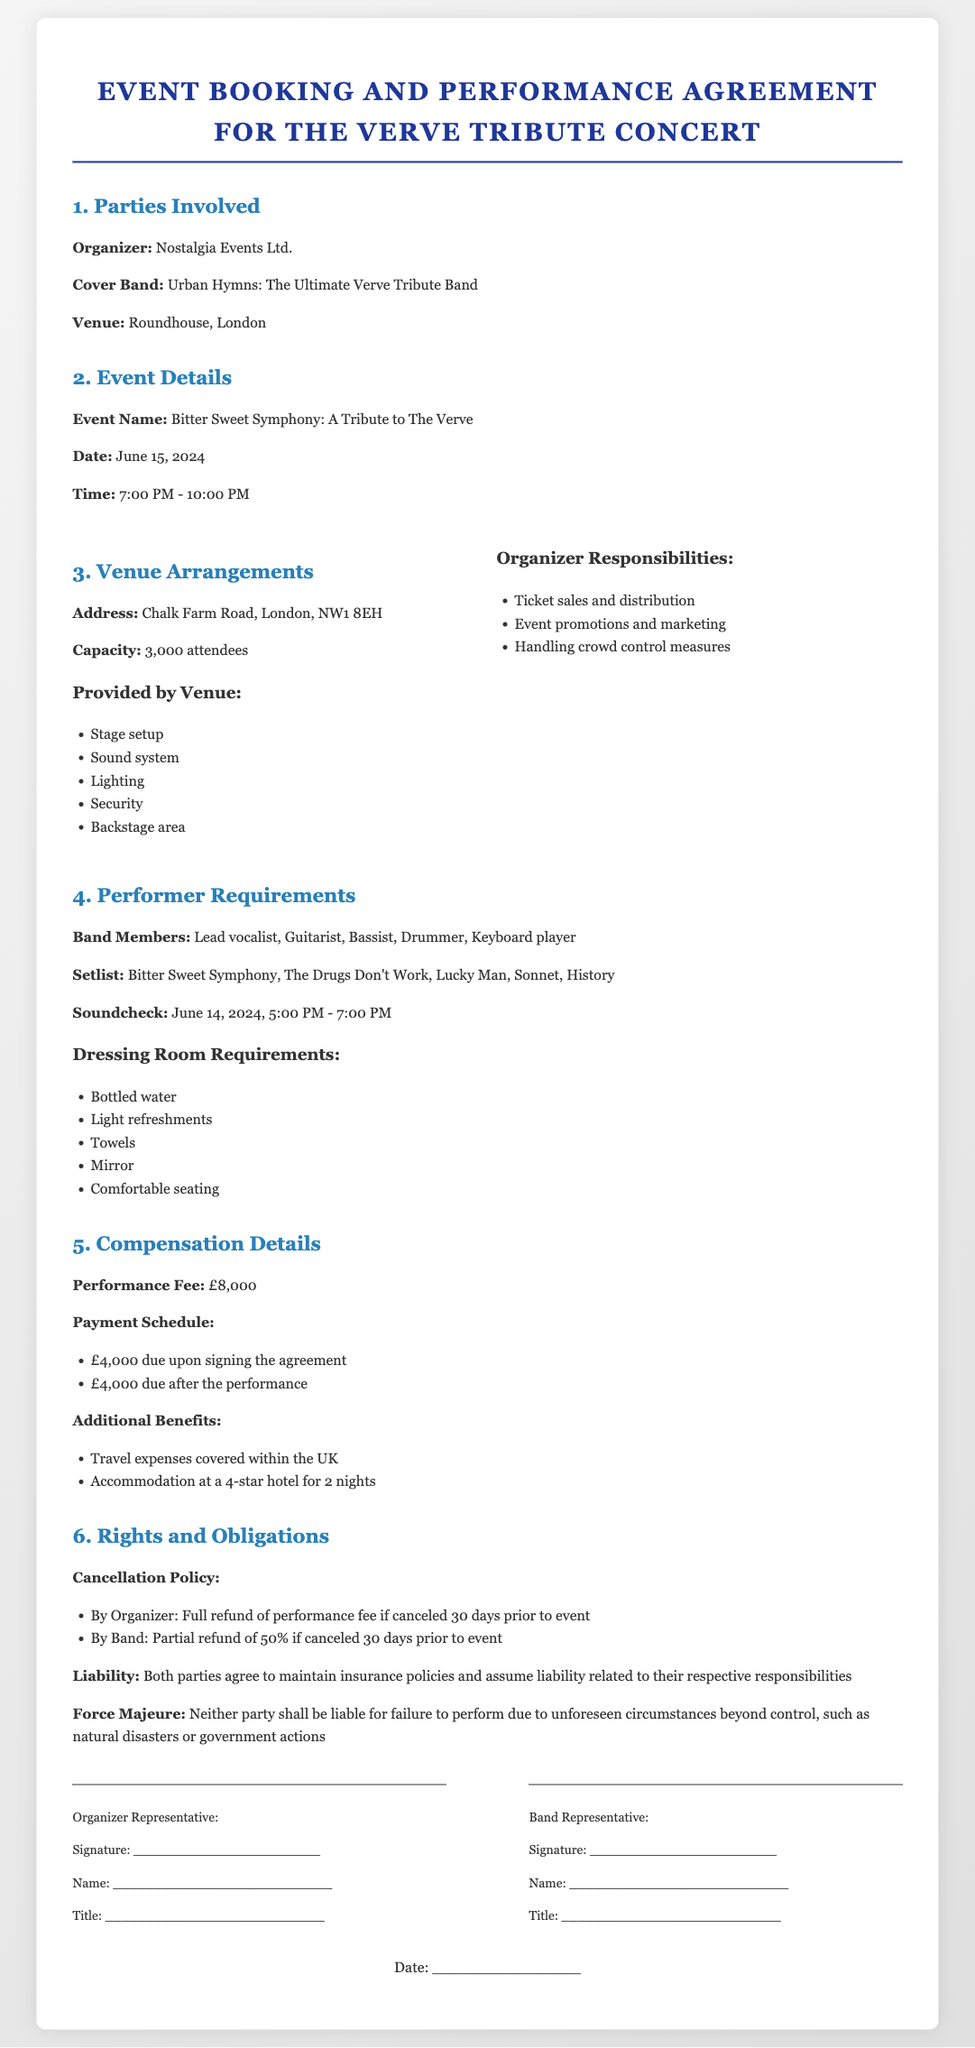What is the name of the organizer? The Organizer is listed in the document as Nostalgia Events Ltd.
Answer: Nostalgia Events Ltd What is the performance fee? The performance fee is explicitly stated in the document, which outlines the financial arrangements for the performance.
Answer: £8,000 What is the date of the event? The date of the event is relevant for planning and scheduling purposes; it is specified in the event details section.
Answer: June 15, 2024 How many attendees can the venue accommodate? The capacity of the venue is mentioned in the venue arrangements section, indicating how many attendees can be safely accommodated.
Answer: 3,000 attendees What is the payment due upon signing the agreement? The payment schedule outlines the financial obligations, including the amount due upfront when the contract is signed.
Answer: £4,000 What should be included in the dressing room? The requirements for the dressing room are provided to ensure the band has a comfortable environment before performing.
Answer: Bottled water, light refreshments, towels, mirror, comfortable seating What is the cancellation policy for the band? The cancellation policy specifies the conditions under which the band can cancel the agreement and the financial repercussions of that cancellation.
Answer: Partial refund of 50% if canceled 30 days prior to event What responsibilities does the organizer have? The organizer's responsibilities are crucial for event success and are detailed in the document.
Answer: Ticket sales and distribution, event promotions and marketing, handling crowd control measures What is the soundcheck time? The soundcheck time is crucial for the band's preparation and is detailed in the performer requirements section.
Answer: June 14, 2024, 5:00 PM - 7:00 PM 